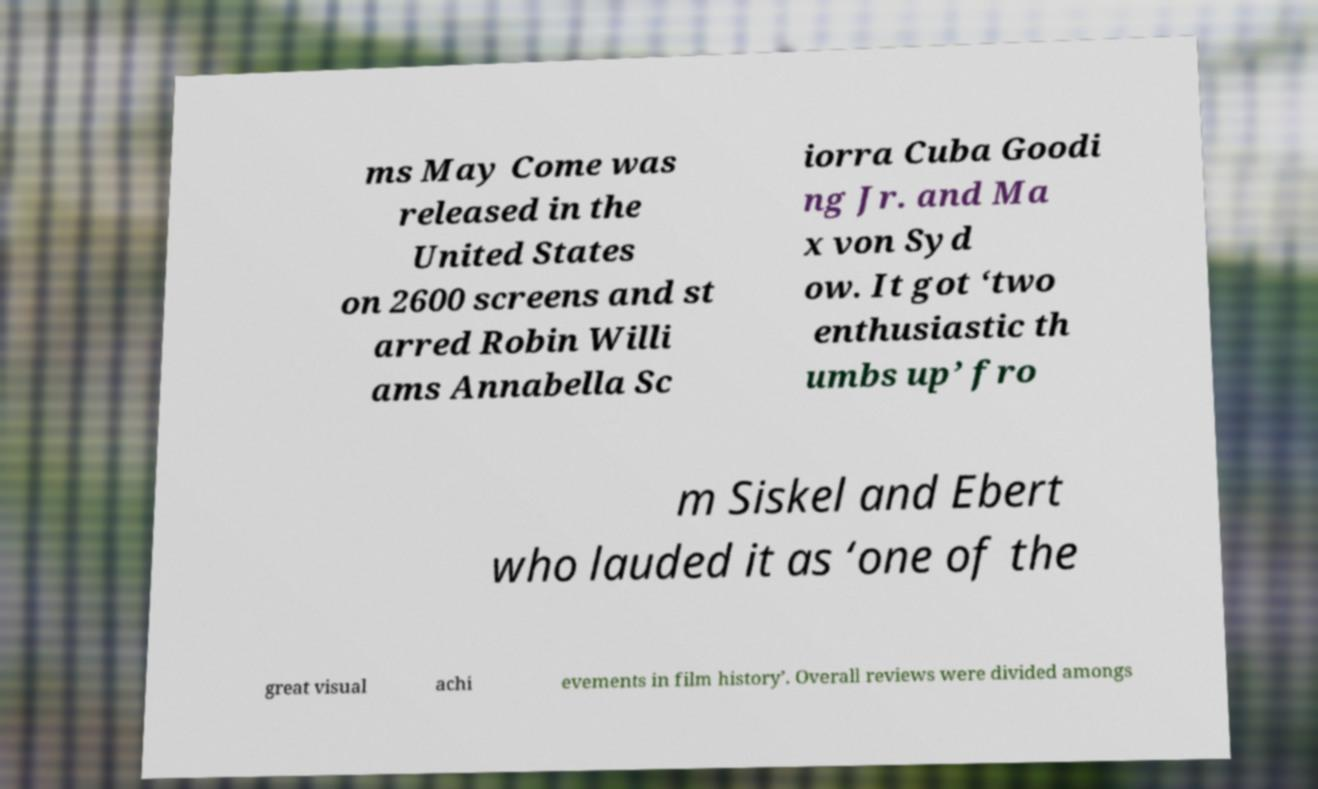For documentation purposes, I need the text within this image transcribed. Could you provide that? ms May Come was released in the United States on 2600 screens and st arred Robin Willi ams Annabella Sc iorra Cuba Goodi ng Jr. and Ma x von Syd ow. It got ‘two enthusiastic th umbs up’ fro m Siskel and Ebert who lauded it as ‘one of the great visual achi evements in film history’. Overall reviews were divided amongs 